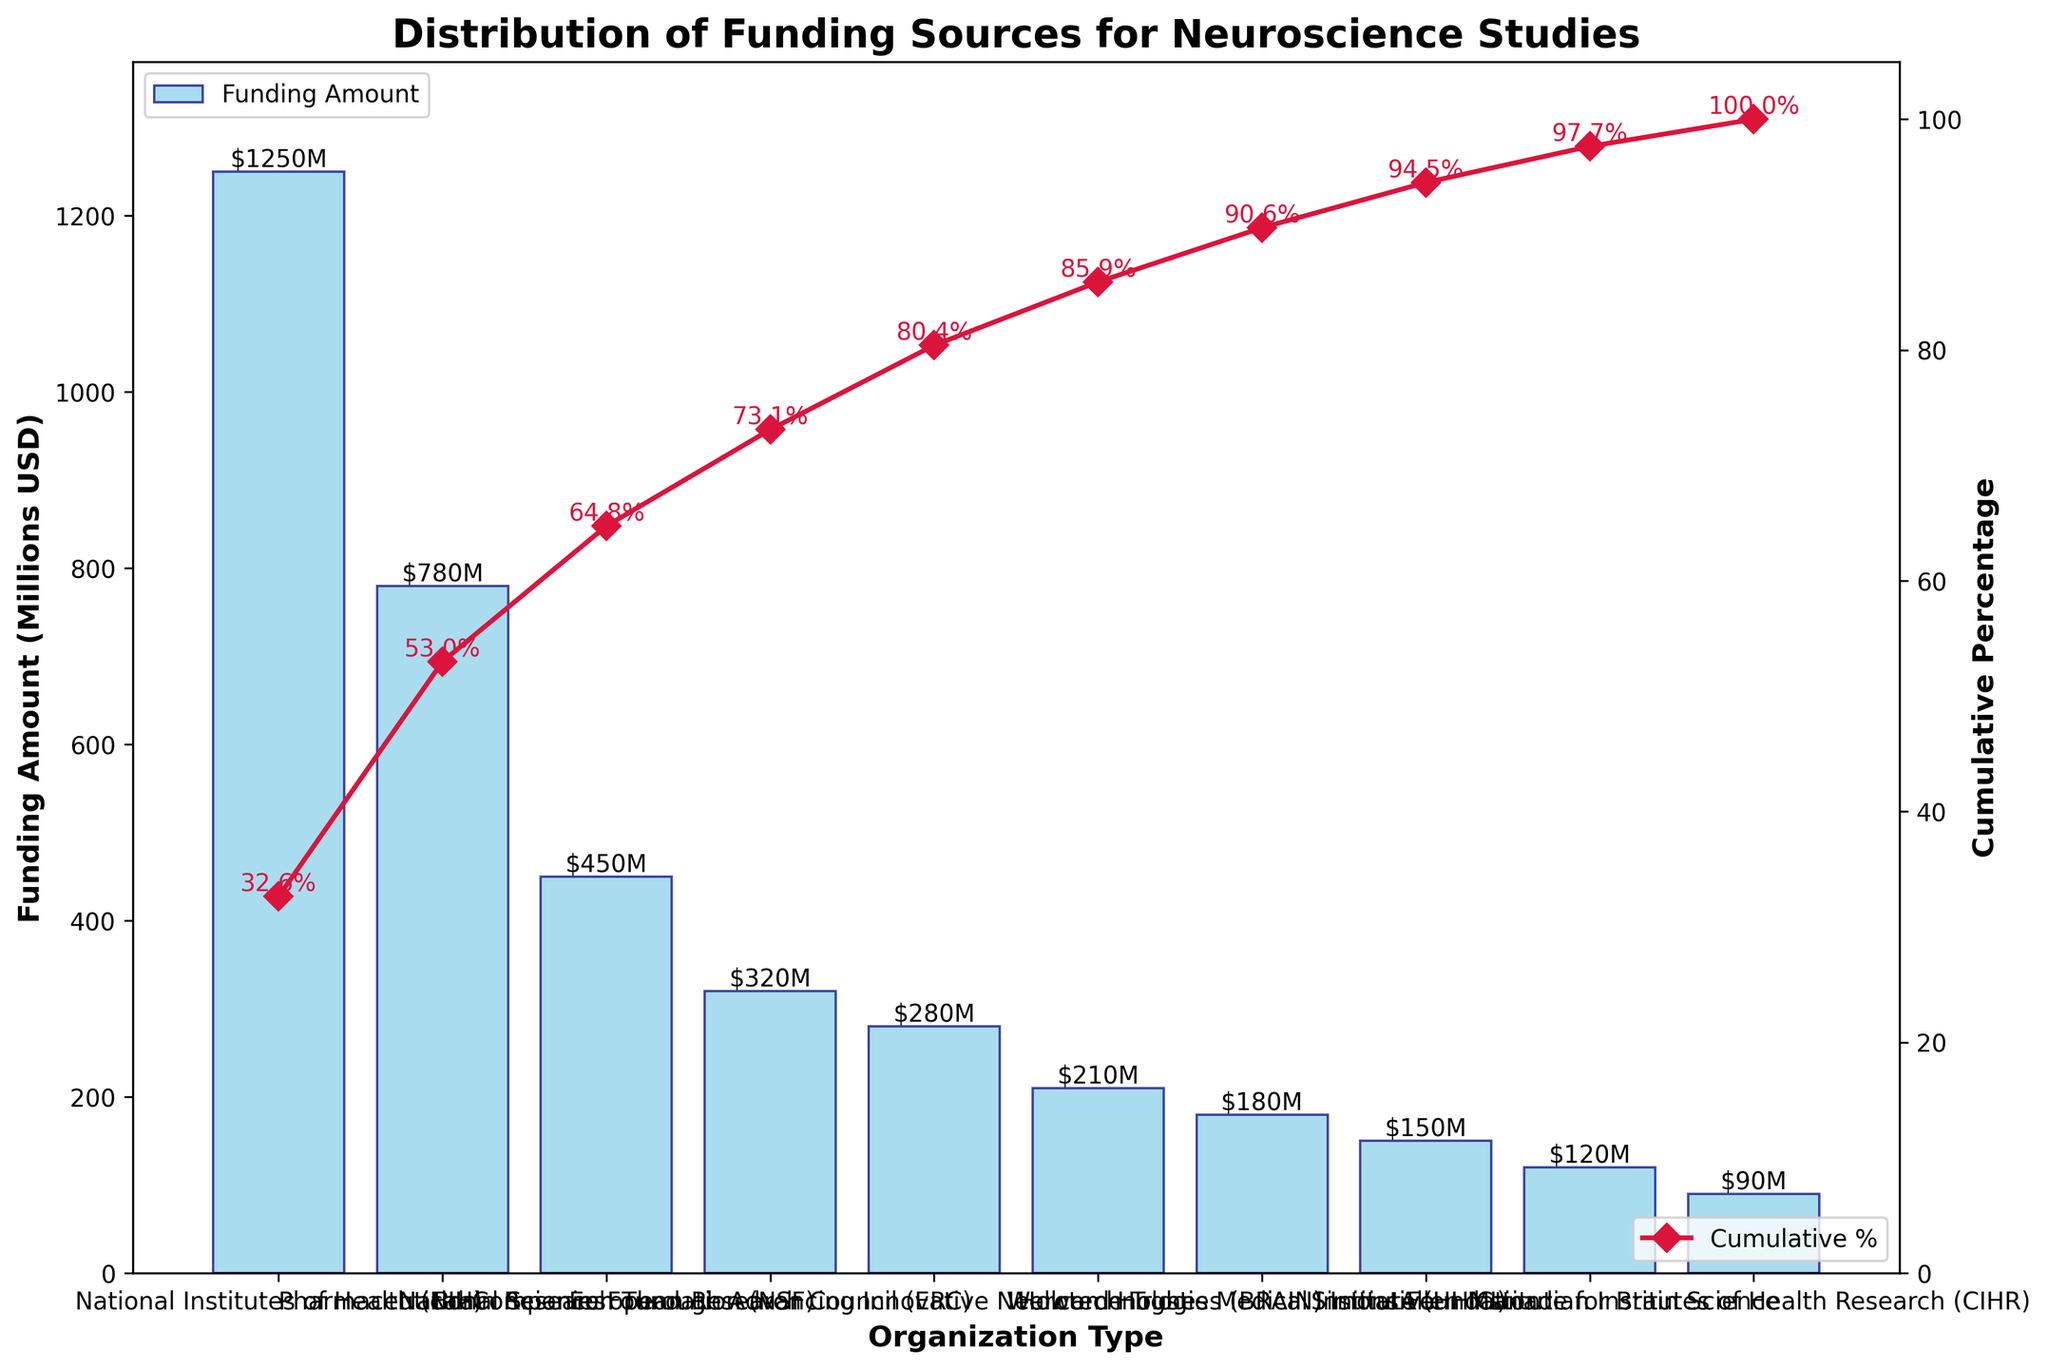Which organization received the highest funding amount? The organization with the tallest bar on the chart, specifically the 'National Institutes of Health (NIH)', indicates the highest funding amount. The bar's height reaches around $1250M.
Answer: National Institutes of Health (NIH) What is the cumulative percentage after the top two highest funding organizations? Identify the first two organizations with the highest funding: 'National Institutes of Health (NIH)' and 'Pharmaceutical Companies'. Add their funding amounts: 1250M + 780M = 2030M. Calculate the cumulative percentage: (2030M / 3850M) * 100 ≈ 52.7%.
Answer: 52.7% Which organization ranks fifth in terms of funding amount? Listing the organizations by their descending funding amounts, the fifth organization is 'Brain Research Through Advancing Innovative Neurotechnologies (BRAIN) Initiative' with a funding of $280M.
Answer: BRAIN Initiative Is the cumulative percentage at the sixth organization more or less than 80%? Look at the cumulative percentage plotted line. At the sixth position, the cumulative percentage is around 77.3%, which is less than 80%.
Answer: Less than 80% What is the funding difference between the National Institutes of Health (NIH) and the Allen Institute for Brain Science? Subtract the amount of funding for the 'Allen Institute for Brain Science' ($120M) from the 'National Institutes of Health (NIH)' ($1250M). The difference is 1250M - 120M = 1130M.
Answer: 1130M Among the listed organizations, which has the least funding and what is the amount? The shortest bar in the figure represents the organization with the least funding which is the 'Canadian Institutes of Health Research (CIHR)' with $90M.
Answer: Canadian Institutes of Health Research (CIHR), $90M Does the combination of funding from the National Science Foundation (NSF) and European Research Council (ERC) exceed that of the 'Pharmaceutical Companies'? Add the funding of NSF ($450M) and ERC ($320M), which equals 770M. This amount is less than the Pharmaceutical Companies’ funding of $780M.
Answer: No What percentage of the total funding do the top three organizations cover? The top three organizations are 'NIH', 'Pharmaceutical Companies', and 'NSF'. Their total funding is 1250M + 780M + 450M = 2480M. Calculate the percentage: (2480M / 3850M) * 100 ≈ 64.4%.
Answer: 64.4% What is the funding amount represented by the bar immediately following the 'Wellcome Trust'? The 'Howard Hughes Medical Institute (HHMI)' follows 'Wellcome Trust' in the funding amount, representing $180M.
Answer: $180M Can the National Science Foundation (NSF) funding exceed the cumulative funding percentage by the first four organizations? Cumulative funding of the first four: NIH ($1250M), Pharmaceutical Companies ($780M), NSF ($450M), and ERC ($320M) totals 2800M. Adding NSF would sum up to 3250M. The total cumulative funding is (3250M / 3850M) * 100 ≈ 84.4%.
Answer: Yes 